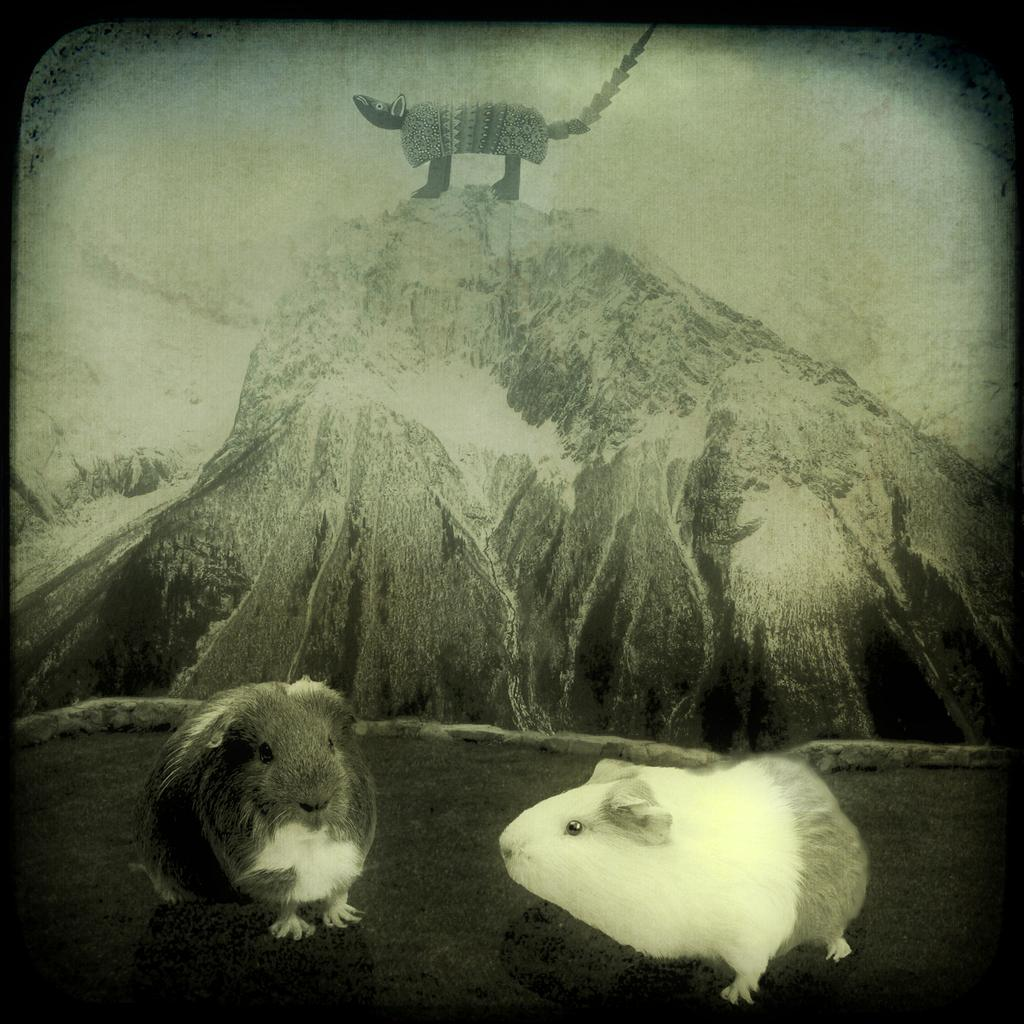What is the color scheme of the image? The image is black and white. How many rats are shown in the image? There are three rats depicted in the image. Where are two of the rats located? Two of the rats are on the land. Where is the third rat located? One rat is on a rock hill. Does the image have any edges or boundaries? Yes, the image has borders. What songs are the rats singing in the image? There is: There are no songs or singing rats in the image; it only depicts rats in different locations. What is the stomach condition of the rat on the rock hill? There is no information about the stomach condition of the rat on the rock hill in the image. 